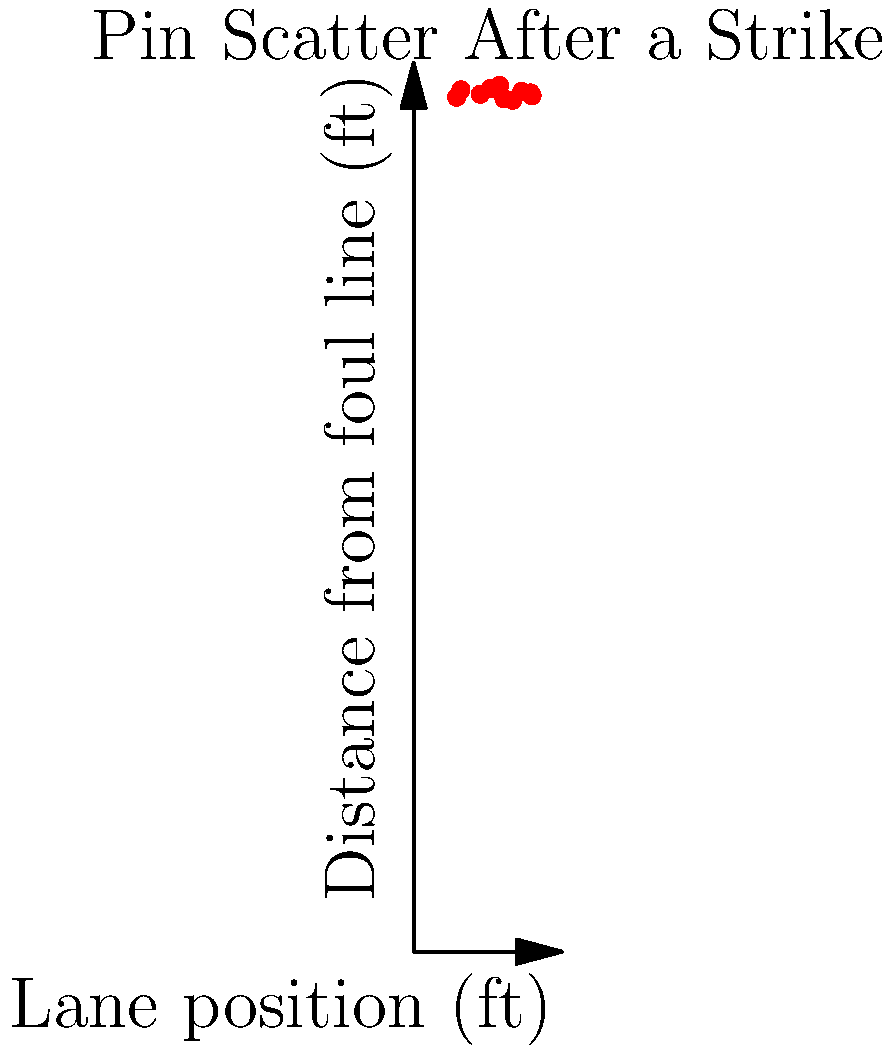As a passionate bowler inspired by women's achievements in sports, you're analyzing the pin scatter patterns after a perfect strike thrown by Liz Johnson, the first woman to win a PBA Tour title. The scatter plot shows the positions of 10 pins after they were knocked down. What does the clustering of data points in the plot suggest about the effectiveness of Liz's strike? To analyze the effectiveness of Liz Johnson's strike based on the pin scatter pattern, let's examine the scatter plot step-by-step:

1. Observe the x-axis: It represents the lane position in feet, ranging from 0 to 10 feet.
2. Observe the y-axis: It shows the distance from the foul line in feet, ranging from 0 to 60 feet.
3. Notice the distribution of data points:
   a. The x-coordinates are spread out between approximately 2.9 and 8.0 feet.
   b. The y-coordinates are tightly clustered between about 57.5 and 58.5 feet.
4. Interpret the x-axis spread:
   - The wide distribution across the lane width indicates that the pins were scattered across most of the lane's width.
   - This suggests a powerful and well-placed strike that effectively spread the pins.
5. Interpret the y-axis clustering:
   - The tight clustering around 58 feet (near the end of a regulation lane) indicates that most pins traveled a similar distance.
   - This suggests consistent power transfer from the ball to the pins.
6. Overall pattern analysis:
   - The combination of wide lateral spread and tight longitudinal clustering suggests an ideal "pocket hit."
   - A pocket hit occurs when the ball strikes between the 1 and 3 pins for right-handed bowlers or 1 and 2 pins for left-handed bowlers.
   - This type of hit typically results in the most effective pin action and highest likelihood of a strike.

Given these observations, the clustering of data points suggests that Liz Johnson's strike was highly effective, demonstrating power, accuracy, and optimal pin action characteristic of professional-level bowling.
Answer: The tight vertical clustering with wide horizontal spread indicates a powerful, accurate pocket hit, demonstrating Liz Johnson's highly effective strike technique. 